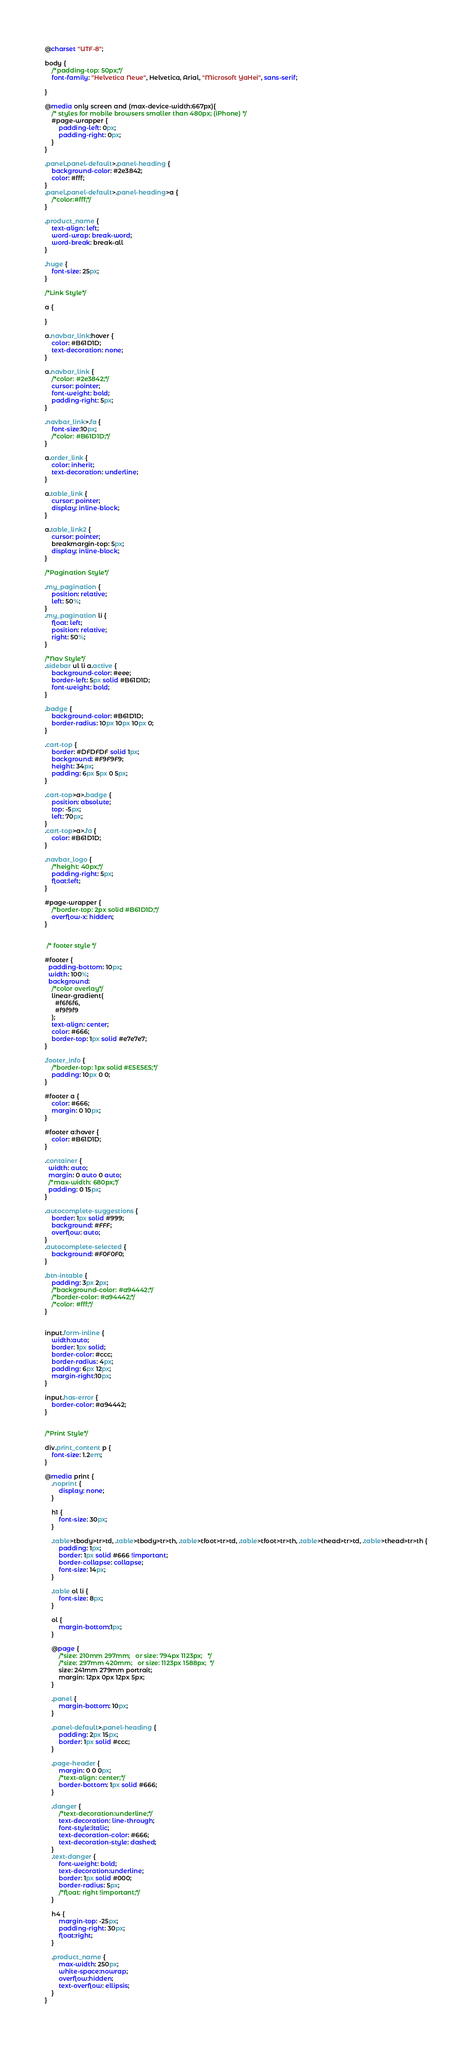Convert code to text. <code><loc_0><loc_0><loc_500><loc_500><_CSS_>@charset "UTF-8";

body {
    /*padding-top: 50px;*/
    font-family: "Helvetica Neue", Helvetica, Arial, "Microsoft YaHei", sans-serif;
    
}

@media only screen and (max-device-width:667px){
    /* styles for mobile browsers smaller than 480px; (iPhone) */
    #page-wrapper {
        padding-left: 0px;
        padding-right: 0px;
    }
}

.panel.panel-default>.panel-heading {
    background-color: #2e3842;
    color: #fff;
}
.panel.panel-default>.panel-heading>a {
    /*color:#fff;*/
}

.product_name {
    text-align: left;
    word-wrap: break-word;
    word-break: break-all
}

.huge {
    font-size: 25px;
}

/*Link Style*/

a {
    
}

a.navbar_link:hover {
    color: #B61D1D;
    text-decoration: none;
}

a.navbar_link {
    /*color: #2e3842;*/
    cursor: pointer;
    font-weight: bold;
    padding-right: 5px;
}

.navbar_link>.fa {
    font-size:10px;
    /*color: #B61D1D;*/
}

a.order_link {
    color: inherit;
    text-decoration: underline;
}

a.table_link {
    cursor: pointer;
    display: inline-block;
}

a.table_link2 {
    cursor: pointer;
    breakmargin-top: 5px;
    display: inline-block;
}

/*Pagination Style*/

.my_pagination {
    position: relative;
    left: 50%;
}
.my_pagination li {
    float: left;
    position: relative;
    right: 50%;
}

/*Nav Style*/
.sidebar ul li a.active {
    background-color: #eee;
    border-left: 5px solid #B61D1D;
    font-weight: bold;
}

.badge {
    background-color: #B61D1D;
    border-radius: 10px 10px 10px 0;  
}

.cart-top {
    border: #DFDFDF solid 1px; 
    background: #F9F9F9; 
    height: 34px; 
    padding: 6px 5px 0 5px;
}

.cart-top>a>.badge {    
    position: absolute;
    top: -5px;
    left: 70px;
}
.cart-top>a>.fa {
    color: #B61D1D;
}

.navbar_logo {
    /*height: 40px;*/
    padding-right: 5px;
    float:left;
}

#page-wrapper {
    /*border-top: 2px solid #B61D1D;*/
    overflow-x: hidden;
}


 /* footer style */

#footer {
  padding-bottom: 10px;
  width: 100%;
  background: 
    /*color overlay*/
    linear-gradient(
      #f6f6f6,
      #f9f9f9
    );    
    text-align: center;
    color: #666;
    border-top: 1px solid #e7e7e7;
}

.footer_info {
    /*border-top: 1px solid #E5E5E5;*/
    padding: 10px 0 0;
}

#footer a {
    color: #666;
    margin: 0 10px;
}

#footer a:hover {
    color: #B61D1D;
}

.container {
  width: auto;
  margin: 0 auto 0 auto;
  /*max-width: 680px;*/
  padding: 0 15px;
}

.autocomplete-suggestions {
    border: 1px solid #999; 
    background: #FFF; 
    overflow: auto;
}
.autocomplete-selected { 
    background: #F0F0F0; 
}

.btn-intable {
    padding: 3px 2px;
    /*background-color: #a94442;*/
    /*border-color: #a94442;*/
    /*color: #fff;*/
}


input.form-inline {
    width:auto; 
    border: 1px solid;
    border-color: #ccc;
    border-radius: 4px; 
    padding: 6px 12px;
    margin-right:10px;
}

input.has-error {
    border-color: #a94442;
}


/*Print Style*/

div.print_content p {
    font-size: 1.2em;
}

@media print {
    .noprint {
        display: none;
    }

    h1 {
        font-size: 30px;
    }

    .table>tbody>tr>td, .table>tbody>tr>th, .table>tfoot>tr>td, .table>tfoot>tr>th, .table>thead>tr>td, .table>thead>tr>th {
        padding: 1px;
        border: 1px solid #666 !important;
        border-collapse: collapse;
        font-size: 14px;
    }

    .table ol li {
        font-size: 8px;
    }

    ol {
        margin-bottom:1px;
    }

    @page {
        /*size: 210mm 297mm;   or size: 794px 1123px;   */
        /*size: 297mm 420mm;   or size: 1123px 1588px;  */
        size: 241mm 279mm portrait;
        margin: 12px 0px 12px 5px;
    }

    .panel {
        margin-bottom: 10px;
    }

    .panel-default>.panel-heading {
        padding: 2px 15px;
        border: 1px solid #ccc;
    }

    .page-header {
        margin: 0 0 0px;
        /*text-align: center;*/        
        border-bottom: 1px solid #666;
    }

    .danger {
        /*text-decoration:underline;*/
        text-decoration: line-through;
        font-style:italic;        
        text-decoration-color: #666;
        text-decoration-style: dashed;
    }
    .text-danger {
        font-weight: bold;
        text-decoration:underline;   
        border: 1px solid #000;
        border-radius: 5px;
        /*float: right !important;*/
    }

    h4 {
        margin-top: -25px;
        padding-right: 30px;
        float:right;
    }

    .product_name {
        max-width: 250px;
        white-space:nowrap;
        overflow:hidden;
        text-overflow: ellipsis;
    }
}
</code> 